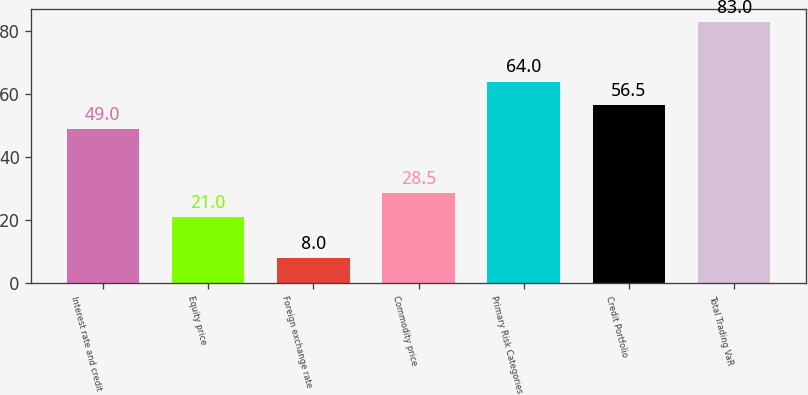Convert chart. <chart><loc_0><loc_0><loc_500><loc_500><bar_chart><fcel>Interest rate and credit<fcel>Equity price<fcel>Foreign exchange rate<fcel>Commodity price<fcel>Primary Risk Categories<fcel>Credit Portfolio<fcel>Total Trading VaR<nl><fcel>49<fcel>21<fcel>8<fcel>28.5<fcel>64<fcel>56.5<fcel>83<nl></chart> 